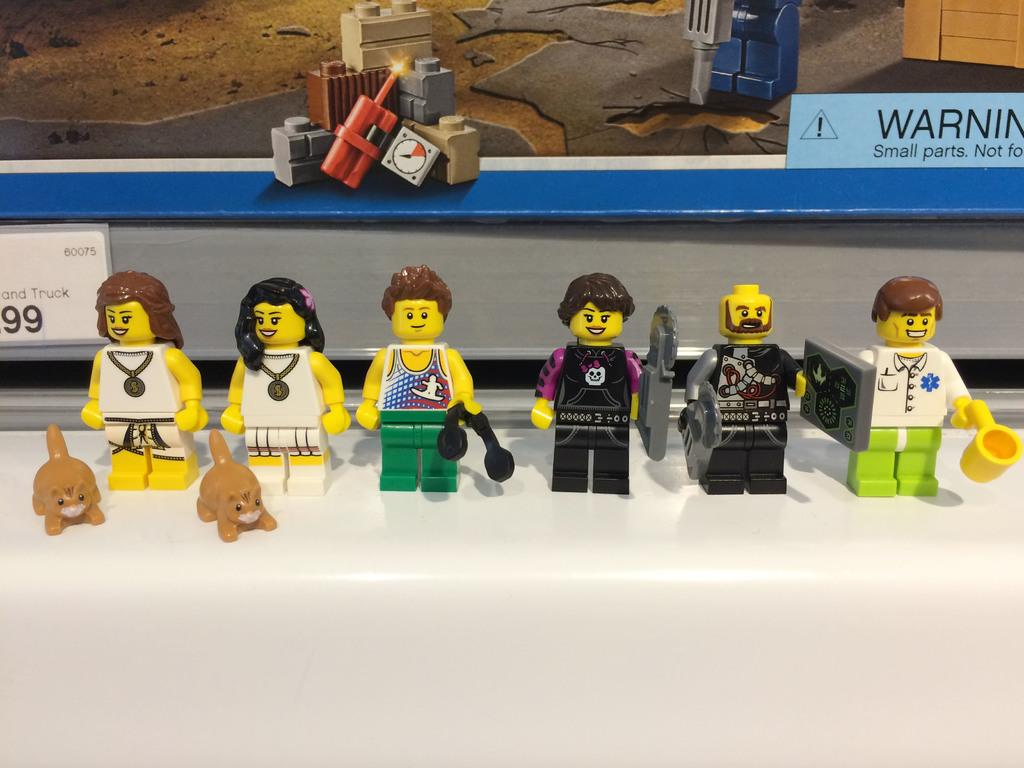What objects can be seen in the image? There are toys in the image. Can you describe the board in the background of the image? There is a board with toys and text written on it in the background of the image. What type of yoke is being used to lift the toys in the image? There is no yoke or lifting action depicted in the image; the toys are simply placed on the board. 